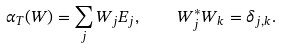<formula> <loc_0><loc_0><loc_500><loc_500>\alpha _ { T } ( W ) = \sum _ { j } W _ { j } E _ { j } , \quad W _ { j } ^ { * } W _ { k } = \delta _ { j , k } .</formula> 